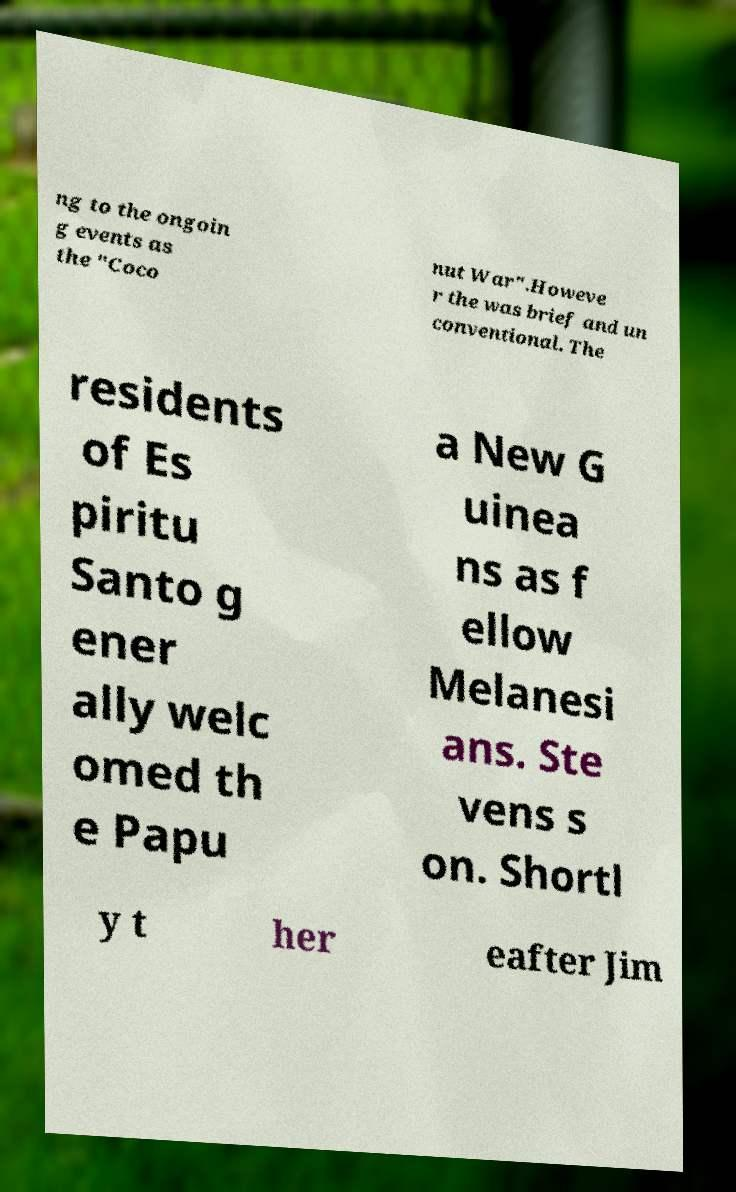Could you assist in decoding the text presented in this image and type it out clearly? ng to the ongoin g events as the "Coco nut War".Howeve r the was brief and un conventional. The residents of Es piritu Santo g ener ally welc omed th e Papu a New G uinea ns as f ellow Melanesi ans. Ste vens s on. Shortl y t her eafter Jim 